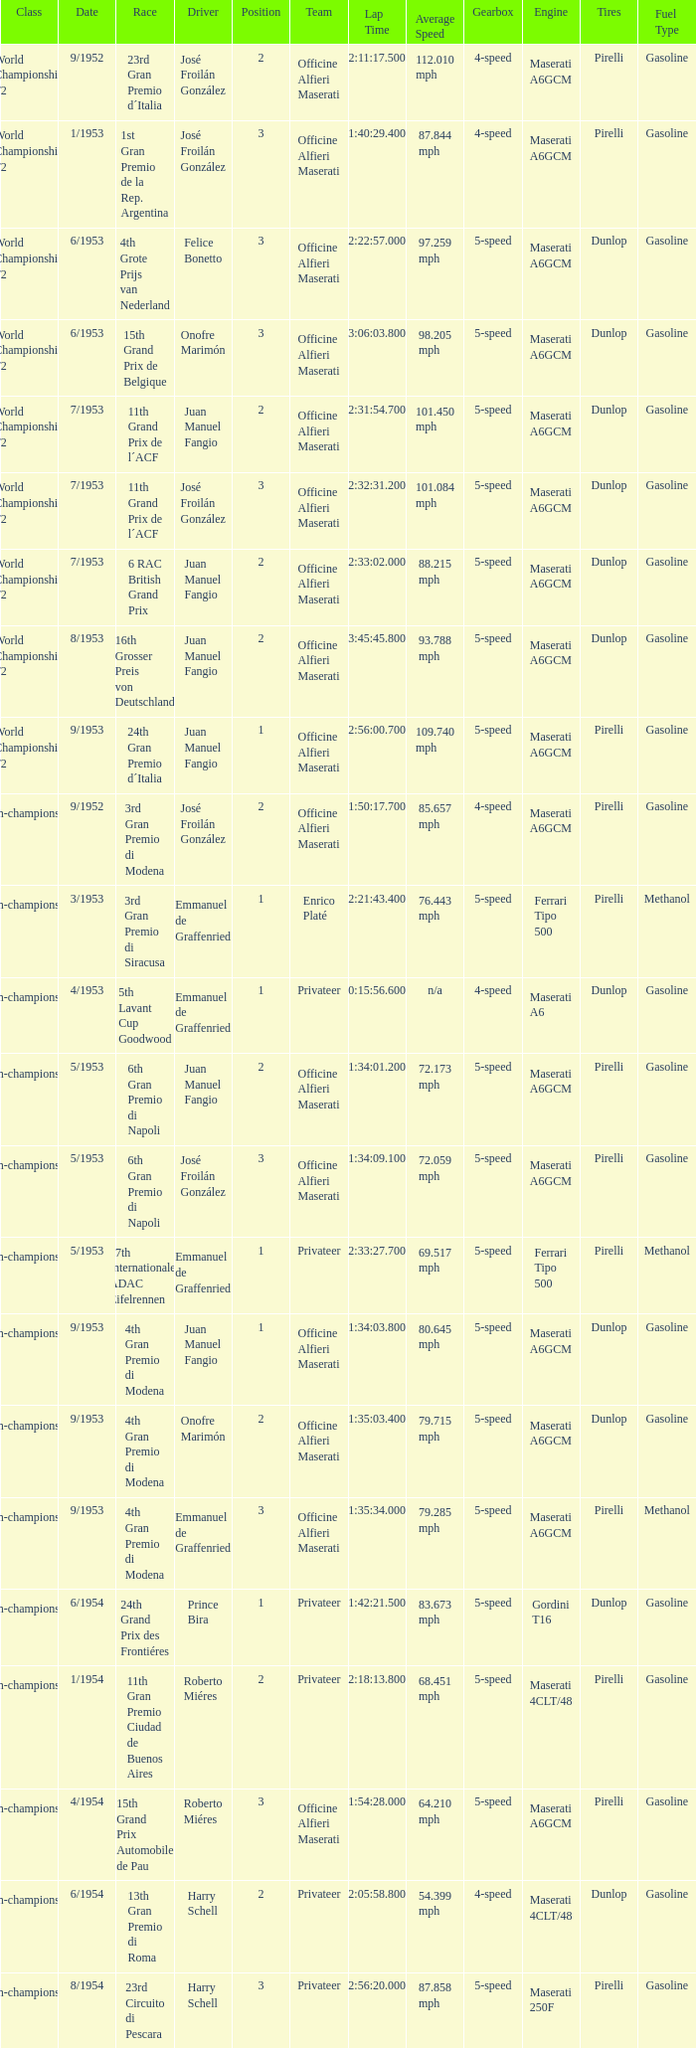What team has a drive name emmanuel de graffenried and a position larger than 1 as well as the date of 9/1953? Officine Alfieri Maserati. 